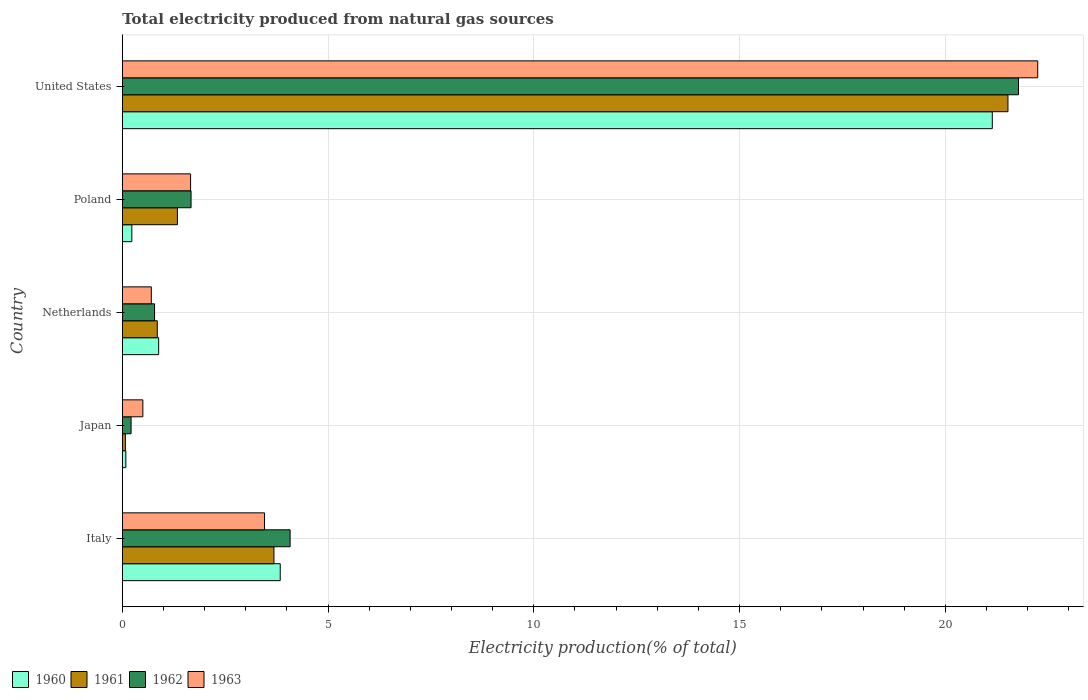How many different coloured bars are there?
Offer a very short reply. 4. Are the number of bars per tick equal to the number of legend labels?
Provide a succinct answer. Yes. How many bars are there on the 3rd tick from the top?
Provide a succinct answer. 4. How many bars are there on the 2nd tick from the bottom?
Offer a terse response. 4. In how many cases, is the number of bars for a given country not equal to the number of legend labels?
Your response must be concise. 0. What is the total electricity produced in 1962 in Poland?
Make the answer very short. 1.67. Across all countries, what is the maximum total electricity produced in 1963?
Your response must be concise. 22.24. Across all countries, what is the minimum total electricity produced in 1960?
Keep it short and to the point. 0.09. In which country was the total electricity produced in 1961 maximum?
Keep it short and to the point. United States. What is the total total electricity produced in 1960 in the graph?
Make the answer very short. 26.18. What is the difference between the total electricity produced in 1960 in Italy and that in United States?
Your answer should be very brief. -17.3. What is the difference between the total electricity produced in 1960 in United States and the total electricity produced in 1962 in Netherlands?
Provide a succinct answer. 20.36. What is the average total electricity produced in 1962 per country?
Provide a succinct answer. 5.71. What is the difference between the total electricity produced in 1963 and total electricity produced in 1962 in Poland?
Offer a very short reply. -0.01. What is the ratio of the total electricity produced in 1960 in Italy to that in Poland?
Make the answer very short. 16.53. What is the difference between the highest and the second highest total electricity produced in 1961?
Your answer should be compact. 17.84. What is the difference between the highest and the lowest total electricity produced in 1961?
Give a very brief answer. 21.45. In how many countries, is the total electricity produced in 1961 greater than the average total electricity produced in 1961 taken over all countries?
Make the answer very short. 1. Is the sum of the total electricity produced in 1962 in Italy and Poland greater than the maximum total electricity produced in 1960 across all countries?
Your answer should be very brief. No. Is it the case that in every country, the sum of the total electricity produced in 1961 and total electricity produced in 1963 is greater than the sum of total electricity produced in 1960 and total electricity produced in 1962?
Offer a terse response. No. What does the 1st bar from the top in Netherlands represents?
Provide a succinct answer. 1963. What does the 1st bar from the bottom in Italy represents?
Your answer should be very brief. 1960. What is the difference between two consecutive major ticks on the X-axis?
Ensure brevity in your answer.  5. Does the graph contain grids?
Ensure brevity in your answer.  Yes. How many legend labels are there?
Offer a very short reply. 4. How are the legend labels stacked?
Offer a terse response. Horizontal. What is the title of the graph?
Your answer should be very brief. Total electricity produced from natural gas sources. What is the Electricity production(% of total) in 1960 in Italy?
Your answer should be compact. 3.84. What is the Electricity production(% of total) in 1961 in Italy?
Give a very brief answer. 3.69. What is the Electricity production(% of total) in 1962 in Italy?
Offer a terse response. 4.08. What is the Electricity production(% of total) of 1963 in Italy?
Your response must be concise. 3.46. What is the Electricity production(% of total) of 1960 in Japan?
Your answer should be compact. 0.09. What is the Electricity production(% of total) of 1961 in Japan?
Make the answer very short. 0.08. What is the Electricity production(% of total) in 1962 in Japan?
Offer a terse response. 0.21. What is the Electricity production(% of total) of 1963 in Japan?
Give a very brief answer. 0.5. What is the Electricity production(% of total) of 1960 in Netherlands?
Ensure brevity in your answer.  0.88. What is the Electricity production(% of total) of 1961 in Netherlands?
Offer a terse response. 0.85. What is the Electricity production(% of total) of 1962 in Netherlands?
Offer a terse response. 0.78. What is the Electricity production(% of total) of 1963 in Netherlands?
Give a very brief answer. 0.71. What is the Electricity production(% of total) of 1960 in Poland?
Give a very brief answer. 0.23. What is the Electricity production(% of total) of 1961 in Poland?
Provide a short and direct response. 1.34. What is the Electricity production(% of total) of 1962 in Poland?
Offer a terse response. 1.67. What is the Electricity production(% of total) of 1963 in Poland?
Your answer should be very brief. 1.66. What is the Electricity production(% of total) of 1960 in United States?
Make the answer very short. 21.14. What is the Electricity production(% of total) in 1961 in United States?
Offer a terse response. 21.52. What is the Electricity production(% of total) in 1962 in United States?
Ensure brevity in your answer.  21.78. What is the Electricity production(% of total) of 1963 in United States?
Give a very brief answer. 22.24. Across all countries, what is the maximum Electricity production(% of total) in 1960?
Offer a terse response. 21.14. Across all countries, what is the maximum Electricity production(% of total) of 1961?
Offer a terse response. 21.52. Across all countries, what is the maximum Electricity production(% of total) of 1962?
Your response must be concise. 21.78. Across all countries, what is the maximum Electricity production(% of total) of 1963?
Provide a short and direct response. 22.24. Across all countries, what is the minimum Electricity production(% of total) in 1960?
Provide a succinct answer. 0.09. Across all countries, what is the minimum Electricity production(% of total) in 1961?
Provide a short and direct response. 0.08. Across all countries, what is the minimum Electricity production(% of total) in 1962?
Provide a succinct answer. 0.21. Across all countries, what is the minimum Electricity production(% of total) in 1963?
Your answer should be compact. 0.5. What is the total Electricity production(% of total) in 1960 in the graph?
Your response must be concise. 26.18. What is the total Electricity production(% of total) of 1961 in the graph?
Ensure brevity in your answer.  27.47. What is the total Electricity production(% of total) of 1962 in the graph?
Give a very brief answer. 28.53. What is the total Electricity production(% of total) in 1963 in the graph?
Provide a succinct answer. 28.57. What is the difference between the Electricity production(% of total) in 1960 in Italy and that in Japan?
Make the answer very short. 3.75. What is the difference between the Electricity production(% of total) in 1961 in Italy and that in Japan?
Offer a terse response. 3.61. What is the difference between the Electricity production(% of total) in 1962 in Italy and that in Japan?
Make the answer very short. 3.86. What is the difference between the Electricity production(% of total) in 1963 in Italy and that in Japan?
Your response must be concise. 2.96. What is the difference between the Electricity production(% of total) of 1960 in Italy and that in Netherlands?
Provide a short and direct response. 2.95. What is the difference between the Electricity production(% of total) of 1961 in Italy and that in Netherlands?
Your response must be concise. 2.83. What is the difference between the Electricity production(% of total) in 1962 in Italy and that in Netherlands?
Offer a very short reply. 3.29. What is the difference between the Electricity production(% of total) in 1963 in Italy and that in Netherlands?
Make the answer very short. 2.75. What is the difference between the Electricity production(% of total) of 1960 in Italy and that in Poland?
Provide a succinct answer. 3.61. What is the difference between the Electricity production(% of total) of 1961 in Italy and that in Poland?
Your answer should be compact. 2.35. What is the difference between the Electricity production(% of total) in 1962 in Italy and that in Poland?
Give a very brief answer. 2.41. What is the difference between the Electricity production(% of total) in 1963 in Italy and that in Poland?
Offer a terse response. 1.8. What is the difference between the Electricity production(% of total) of 1960 in Italy and that in United States?
Offer a very short reply. -17.3. What is the difference between the Electricity production(% of total) in 1961 in Italy and that in United States?
Your answer should be very brief. -17.84. What is the difference between the Electricity production(% of total) of 1962 in Italy and that in United States?
Your response must be concise. -17.7. What is the difference between the Electricity production(% of total) of 1963 in Italy and that in United States?
Your response must be concise. -18.79. What is the difference between the Electricity production(% of total) in 1960 in Japan and that in Netherlands?
Give a very brief answer. -0.8. What is the difference between the Electricity production(% of total) of 1961 in Japan and that in Netherlands?
Your answer should be very brief. -0.78. What is the difference between the Electricity production(% of total) in 1962 in Japan and that in Netherlands?
Your answer should be compact. -0.57. What is the difference between the Electricity production(% of total) of 1963 in Japan and that in Netherlands?
Keep it short and to the point. -0.21. What is the difference between the Electricity production(% of total) in 1960 in Japan and that in Poland?
Ensure brevity in your answer.  -0.15. What is the difference between the Electricity production(% of total) in 1961 in Japan and that in Poland?
Keep it short and to the point. -1.26. What is the difference between the Electricity production(% of total) in 1962 in Japan and that in Poland?
Keep it short and to the point. -1.46. What is the difference between the Electricity production(% of total) in 1963 in Japan and that in Poland?
Your response must be concise. -1.16. What is the difference between the Electricity production(% of total) in 1960 in Japan and that in United States?
Your response must be concise. -21.05. What is the difference between the Electricity production(% of total) of 1961 in Japan and that in United States?
Offer a terse response. -21.45. What is the difference between the Electricity production(% of total) of 1962 in Japan and that in United States?
Ensure brevity in your answer.  -21.56. What is the difference between the Electricity production(% of total) of 1963 in Japan and that in United States?
Offer a terse response. -21.74. What is the difference between the Electricity production(% of total) in 1960 in Netherlands and that in Poland?
Your response must be concise. 0.65. What is the difference between the Electricity production(% of total) of 1961 in Netherlands and that in Poland?
Offer a very short reply. -0.49. What is the difference between the Electricity production(% of total) of 1962 in Netherlands and that in Poland?
Offer a very short reply. -0.89. What is the difference between the Electricity production(% of total) in 1963 in Netherlands and that in Poland?
Keep it short and to the point. -0.95. What is the difference between the Electricity production(% of total) in 1960 in Netherlands and that in United States?
Offer a very short reply. -20.26. What is the difference between the Electricity production(% of total) of 1961 in Netherlands and that in United States?
Your answer should be very brief. -20.67. What is the difference between the Electricity production(% of total) of 1962 in Netherlands and that in United States?
Your response must be concise. -20.99. What is the difference between the Electricity production(% of total) of 1963 in Netherlands and that in United States?
Ensure brevity in your answer.  -21.54. What is the difference between the Electricity production(% of total) in 1960 in Poland and that in United States?
Make the answer very short. -20.91. What is the difference between the Electricity production(% of total) in 1961 in Poland and that in United States?
Offer a very short reply. -20.18. What is the difference between the Electricity production(% of total) in 1962 in Poland and that in United States?
Your response must be concise. -20.11. What is the difference between the Electricity production(% of total) in 1963 in Poland and that in United States?
Keep it short and to the point. -20.59. What is the difference between the Electricity production(% of total) of 1960 in Italy and the Electricity production(% of total) of 1961 in Japan?
Make the answer very short. 3.76. What is the difference between the Electricity production(% of total) in 1960 in Italy and the Electricity production(% of total) in 1962 in Japan?
Provide a succinct answer. 3.62. What is the difference between the Electricity production(% of total) of 1960 in Italy and the Electricity production(% of total) of 1963 in Japan?
Your answer should be very brief. 3.34. What is the difference between the Electricity production(% of total) in 1961 in Italy and the Electricity production(% of total) in 1962 in Japan?
Provide a short and direct response. 3.47. What is the difference between the Electricity production(% of total) of 1961 in Italy and the Electricity production(% of total) of 1963 in Japan?
Your answer should be very brief. 3.19. What is the difference between the Electricity production(% of total) of 1962 in Italy and the Electricity production(% of total) of 1963 in Japan?
Give a very brief answer. 3.58. What is the difference between the Electricity production(% of total) of 1960 in Italy and the Electricity production(% of total) of 1961 in Netherlands?
Give a very brief answer. 2.99. What is the difference between the Electricity production(% of total) in 1960 in Italy and the Electricity production(% of total) in 1962 in Netherlands?
Your answer should be compact. 3.05. What is the difference between the Electricity production(% of total) in 1960 in Italy and the Electricity production(% of total) in 1963 in Netherlands?
Provide a succinct answer. 3.13. What is the difference between the Electricity production(% of total) in 1961 in Italy and the Electricity production(% of total) in 1962 in Netherlands?
Keep it short and to the point. 2.9. What is the difference between the Electricity production(% of total) in 1961 in Italy and the Electricity production(% of total) in 1963 in Netherlands?
Your response must be concise. 2.98. What is the difference between the Electricity production(% of total) in 1962 in Italy and the Electricity production(% of total) in 1963 in Netherlands?
Your answer should be compact. 3.37. What is the difference between the Electricity production(% of total) of 1960 in Italy and the Electricity production(% of total) of 1961 in Poland?
Provide a succinct answer. 2.5. What is the difference between the Electricity production(% of total) in 1960 in Italy and the Electricity production(% of total) in 1962 in Poland?
Provide a succinct answer. 2.17. What is the difference between the Electricity production(% of total) in 1960 in Italy and the Electricity production(% of total) in 1963 in Poland?
Offer a very short reply. 2.18. What is the difference between the Electricity production(% of total) in 1961 in Italy and the Electricity production(% of total) in 1962 in Poland?
Offer a very short reply. 2.01. What is the difference between the Electricity production(% of total) in 1961 in Italy and the Electricity production(% of total) in 1963 in Poland?
Make the answer very short. 2.03. What is the difference between the Electricity production(% of total) in 1962 in Italy and the Electricity production(% of total) in 1963 in Poland?
Offer a terse response. 2.42. What is the difference between the Electricity production(% of total) in 1960 in Italy and the Electricity production(% of total) in 1961 in United States?
Give a very brief answer. -17.68. What is the difference between the Electricity production(% of total) in 1960 in Italy and the Electricity production(% of total) in 1962 in United States?
Your answer should be very brief. -17.94. What is the difference between the Electricity production(% of total) in 1960 in Italy and the Electricity production(% of total) in 1963 in United States?
Make the answer very short. -18.41. What is the difference between the Electricity production(% of total) of 1961 in Italy and the Electricity production(% of total) of 1962 in United States?
Ensure brevity in your answer.  -18.09. What is the difference between the Electricity production(% of total) in 1961 in Italy and the Electricity production(% of total) in 1963 in United States?
Make the answer very short. -18.56. What is the difference between the Electricity production(% of total) of 1962 in Italy and the Electricity production(% of total) of 1963 in United States?
Your response must be concise. -18.17. What is the difference between the Electricity production(% of total) in 1960 in Japan and the Electricity production(% of total) in 1961 in Netherlands?
Your answer should be very brief. -0.76. What is the difference between the Electricity production(% of total) in 1960 in Japan and the Electricity production(% of total) in 1962 in Netherlands?
Keep it short and to the point. -0.7. What is the difference between the Electricity production(% of total) of 1960 in Japan and the Electricity production(% of total) of 1963 in Netherlands?
Offer a very short reply. -0.62. What is the difference between the Electricity production(% of total) of 1961 in Japan and the Electricity production(% of total) of 1962 in Netherlands?
Give a very brief answer. -0.71. What is the difference between the Electricity production(% of total) of 1961 in Japan and the Electricity production(% of total) of 1963 in Netherlands?
Provide a short and direct response. -0.63. What is the difference between the Electricity production(% of total) in 1962 in Japan and the Electricity production(% of total) in 1963 in Netherlands?
Offer a very short reply. -0.49. What is the difference between the Electricity production(% of total) in 1960 in Japan and the Electricity production(% of total) in 1961 in Poland?
Your response must be concise. -1.25. What is the difference between the Electricity production(% of total) in 1960 in Japan and the Electricity production(% of total) in 1962 in Poland?
Offer a very short reply. -1.58. What is the difference between the Electricity production(% of total) of 1960 in Japan and the Electricity production(% of total) of 1963 in Poland?
Your answer should be very brief. -1.57. What is the difference between the Electricity production(% of total) in 1961 in Japan and the Electricity production(% of total) in 1962 in Poland?
Give a very brief answer. -1.6. What is the difference between the Electricity production(% of total) of 1961 in Japan and the Electricity production(% of total) of 1963 in Poland?
Keep it short and to the point. -1.58. What is the difference between the Electricity production(% of total) in 1962 in Japan and the Electricity production(% of total) in 1963 in Poland?
Offer a terse response. -1.45. What is the difference between the Electricity production(% of total) of 1960 in Japan and the Electricity production(% of total) of 1961 in United States?
Ensure brevity in your answer.  -21.43. What is the difference between the Electricity production(% of total) in 1960 in Japan and the Electricity production(% of total) in 1962 in United States?
Ensure brevity in your answer.  -21.69. What is the difference between the Electricity production(% of total) of 1960 in Japan and the Electricity production(% of total) of 1963 in United States?
Your response must be concise. -22.16. What is the difference between the Electricity production(% of total) in 1961 in Japan and the Electricity production(% of total) in 1962 in United States?
Keep it short and to the point. -21.7. What is the difference between the Electricity production(% of total) in 1961 in Japan and the Electricity production(% of total) in 1963 in United States?
Give a very brief answer. -22.17. What is the difference between the Electricity production(% of total) in 1962 in Japan and the Electricity production(% of total) in 1963 in United States?
Provide a succinct answer. -22.03. What is the difference between the Electricity production(% of total) in 1960 in Netherlands and the Electricity production(% of total) in 1961 in Poland?
Ensure brevity in your answer.  -0.46. What is the difference between the Electricity production(% of total) in 1960 in Netherlands and the Electricity production(% of total) in 1962 in Poland?
Make the answer very short. -0.79. What is the difference between the Electricity production(% of total) in 1960 in Netherlands and the Electricity production(% of total) in 1963 in Poland?
Your answer should be very brief. -0.78. What is the difference between the Electricity production(% of total) of 1961 in Netherlands and the Electricity production(% of total) of 1962 in Poland?
Offer a terse response. -0.82. What is the difference between the Electricity production(% of total) of 1961 in Netherlands and the Electricity production(% of total) of 1963 in Poland?
Make the answer very short. -0.81. What is the difference between the Electricity production(% of total) in 1962 in Netherlands and the Electricity production(% of total) in 1963 in Poland?
Offer a very short reply. -0.88. What is the difference between the Electricity production(% of total) of 1960 in Netherlands and the Electricity production(% of total) of 1961 in United States?
Provide a short and direct response. -20.64. What is the difference between the Electricity production(% of total) in 1960 in Netherlands and the Electricity production(% of total) in 1962 in United States?
Keep it short and to the point. -20.89. What is the difference between the Electricity production(% of total) in 1960 in Netherlands and the Electricity production(% of total) in 1963 in United States?
Your response must be concise. -21.36. What is the difference between the Electricity production(% of total) in 1961 in Netherlands and the Electricity production(% of total) in 1962 in United States?
Your response must be concise. -20.93. What is the difference between the Electricity production(% of total) in 1961 in Netherlands and the Electricity production(% of total) in 1963 in United States?
Give a very brief answer. -21.39. What is the difference between the Electricity production(% of total) in 1962 in Netherlands and the Electricity production(% of total) in 1963 in United States?
Offer a very short reply. -21.46. What is the difference between the Electricity production(% of total) in 1960 in Poland and the Electricity production(% of total) in 1961 in United States?
Offer a very short reply. -21.29. What is the difference between the Electricity production(% of total) in 1960 in Poland and the Electricity production(% of total) in 1962 in United States?
Your answer should be compact. -21.55. What is the difference between the Electricity production(% of total) in 1960 in Poland and the Electricity production(% of total) in 1963 in United States?
Offer a very short reply. -22.01. What is the difference between the Electricity production(% of total) in 1961 in Poland and the Electricity production(% of total) in 1962 in United States?
Ensure brevity in your answer.  -20.44. What is the difference between the Electricity production(% of total) in 1961 in Poland and the Electricity production(% of total) in 1963 in United States?
Make the answer very short. -20.91. What is the difference between the Electricity production(% of total) in 1962 in Poland and the Electricity production(% of total) in 1963 in United States?
Give a very brief answer. -20.57. What is the average Electricity production(% of total) of 1960 per country?
Offer a terse response. 5.24. What is the average Electricity production(% of total) of 1961 per country?
Your response must be concise. 5.49. What is the average Electricity production(% of total) in 1962 per country?
Ensure brevity in your answer.  5.71. What is the average Electricity production(% of total) in 1963 per country?
Offer a very short reply. 5.71. What is the difference between the Electricity production(% of total) in 1960 and Electricity production(% of total) in 1961 in Italy?
Keep it short and to the point. 0.15. What is the difference between the Electricity production(% of total) of 1960 and Electricity production(% of total) of 1962 in Italy?
Your answer should be compact. -0.24. What is the difference between the Electricity production(% of total) of 1960 and Electricity production(% of total) of 1963 in Italy?
Make the answer very short. 0.38. What is the difference between the Electricity production(% of total) of 1961 and Electricity production(% of total) of 1962 in Italy?
Offer a terse response. -0.39. What is the difference between the Electricity production(% of total) in 1961 and Electricity production(% of total) in 1963 in Italy?
Ensure brevity in your answer.  0.23. What is the difference between the Electricity production(% of total) of 1962 and Electricity production(% of total) of 1963 in Italy?
Your response must be concise. 0.62. What is the difference between the Electricity production(% of total) in 1960 and Electricity production(% of total) in 1961 in Japan?
Provide a short and direct response. 0.01. What is the difference between the Electricity production(% of total) in 1960 and Electricity production(% of total) in 1962 in Japan?
Your answer should be very brief. -0.13. What is the difference between the Electricity production(% of total) in 1960 and Electricity production(% of total) in 1963 in Japan?
Make the answer very short. -0.41. What is the difference between the Electricity production(% of total) in 1961 and Electricity production(% of total) in 1962 in Japan?
Make the answer very short. -0.14. What is the difference between the Electricity production(% of total) of 1961 and Electricity production(% of total) of 1963 in Japan?
Provide a short and direct response. -0.42. What is the difference between the Electricity production(% of total) in 1962 and Electricity production(% of total) in 1963 in Japan?
Your response must be concise. -0.29. What is the difference between the Electricity production(% of total) of 1960 and Electricity production(% of total) of 1961 in Netherlands?
Ensure brevity in your answer.  0.03. What is the difference between the Electricity production(% of total) of 1960 and Electricity production(% of total) of 1962 in Netherlands?
Provide a short and direct response. 0.1. What is the difference between the Electricity production(% of total) of 1960 and Electricity production(% of total) of 1963 in Netherlands?
Offer a very short reply. 0.18. What is the difference between the Electricity production(% of total) of 1961 and Electricity production(% of total) of 1962 in Netherlands?
Your answer should be compact. 0.07. What is the difference between the Electricity production(% of total) in 1961 and Electricity production(% of total) in 1963 in Netherlands?
Make the answer very short. 0.15. What is the difference between the Electricity production(% of total) in 1962 and Electricity production(% of total) in 1963 in Netherlands?
Ensure brevity in your answer.  0.08. What is the difference between the Electricity production(% of total) in 1960 and Electricity production(% of total) in 1961 in Poland?
Your answer should be compact. -1.11. What is the difference between the Electricity production(% of total) in 1960 and Electricity production(% of total) in 1962 in Poland?
Offer a very short reply. -1.44. What is the difference between the Electricity production(% of total) of 1960 and Electricity production(% of total) of 1963 in Poland?
Provide a short and direct response. -1.43. What is the difference between the Electricity production(% of total) in 1961 and Electricity production(% of total) in 1962 in Poland?
Give a very brief answer. -0.33. What is the difference between the Electricity production(% of total) in 1961 and Electricity production(% of total) in 1963 in Poland?
Make the answer very short. -0.32. What is the difference between the Electricity production(% of total) of 1962 and Electricity production(% of total) of 1963 in Poland?
Provide a short and direct response. 0.01. What is the difference between the Electricity production(% of total) in 1960 and Electricity production(% of total) in 1961 in United States?
Ensure brevity in your answer.  -0.38. What is the difference between the Electricity production(% of total) in 1960 and Electricity production(% of total) in 1962 in United States?
Provide a short and direct response. -0.64. What is the difference between the Electricity production(% of total) in 1960 and Electricity production(% of total) in 1963 in United States?
Keep it short and to the point. -1.1. What is the difference between the Electricity production(% of total) of 1961 and Electricity production(% of total) of 1962 in United States?
Ensure brevity in your answer.  -0.26. What is the difference between the Electricity production(% of total) of 1961 and Electricity production(% of total) of 1963 in United States?
Your response must be concise. -0.72. What is the difference between the Electricity production(% of total) in 1962 and Electricity production(% of total) in 1963 in United States?
Ensure brevity in your answer.  -0.47. What is the ratio of the Electricity production(% of total) in 1960 in Italy to that in Japan?
Offer a terse response. 44.33. What is the ratio of the Electricity production(% of total) in 1961 in Italy to that in Japan?
Your answer should be very brief. 48.69. What is the ratio of the Electricity production(% of total) of 1962 in Italy to that in Japan?
Provide a succinct answer. 19.09. What is the ratio of the Electricity production(% of total) of 1963 in Italy to that in Japan?
Your answer should be very brief. 6.91. What is the ratio of the Electricity production(% of total) of 1960 in Italy to that in Netherlands?
Give a very brief answer. 4.34. What is the ratio of the Electricity production(% of total) in 1961 in Italy to that in Netherlands?
Ensure brevity in your answer.  4.33. What is the ratio of the Electricity production(% of total) in 1962 in Italy to that in Netherlands?
Give a very brief answer. 5.2. What is the ratio of the Electricity production(% of total) of 1963 in Italy to that in Netherlands?
Ensure brevity in your answer.  4.9. What is the ratio of the Electricity production(% of total) in 1960 in Italy to that in Poland?
Provide a succinct answer. 16.53. What is the ratio of the Electricity production(% of total) in 1961 in Italy to that in Poland?
Make the answer very short. 2.75. What is the ratio of the Electricity production(% of total) of 1962 in Italy to that in Poland?
Provide a short and direct response. 2.44. What is the ratio of the Electricity production(% of total) of 1963 in Italy to that in Poland?
Offer a very short reply. 2.08. What is the ratio of the Electricity production(% of total) in 1960 in Italy to that in United States?
Provide a succinct answer. 0.18. What is the ratio of the Electricity production(% of total) in 1961 in Italy to that in United States?
Your response must be concise. 0.17. What is the ratio of the Electricity production(% of total) in 1962 in Italy to that in United States?
Make the answer very short. 0.19. What is the ratio of the Electricity production(% of total) of 1963 in Italy to that in United States?
Provide a succinct answer. 0.16. What is the ratio of the Electricity production(% of total) of 1960 in Japan to that in Netherlands?
Give a very brief answer. 0.1. What is the ratio of the Electricity production(% of total) of 1961 in Japan to that in Netherlands?
Provide a succinct answer. 0.09. What is the ratio of the Electricity production(% of total) in 1962 in Japan to that in Netherlands?
Keep it short and to the point. 0.27. What is the ratio of the Electricity production(% of total) of 1963 in Japan to that in Netherlands?
Your answer should be compact. 0.71. What is the ratio of the Electricity production(% of total) in 1960 in Japan to that in Poland?
Offer a very short reply. 0.37. What is the ratio of the Electricity production(% of total) of 1961 in Japan to that in Poland?
Keep it short and to the point. 0.06. What is the ratio of the Electricity production(% of total) in 1962 in Japan to that in Poland?
Offer a very short reply. 0.13. What is the ratio of the Electricity production(% of total) of 1963 in Japan to that in Poland?
Your answer should be very brief. 0.3. What is the ratio of the Electricity production(% of total) of 1960 in Japan to that in United States?
Ensure brevity in your answer.  0. What is the ratio of the Electricity production(% of total) in 1961 in Japan to that in United States?
Your answer should be very brief. 0. What is the ratio of the Electricity production(% of total) of 1962 in Japan to that in United States?
Offer a terse response. 0.01. What is the ratio of the Electricity production(% of total) of 1963 in Japan to that in United States?
Keep it short and to the point. 0.02. What is the ratio of the Electricity production(% of total) in 1960 in Netherlands to that in Poland?
Offer a very short reply. 3.81. What is the ratio of the Electricity production(% of total) of 1961 in Netherlands to that in Poland?
Keep it short and to the point. 0.64. What is the ratio of the Electricity production(% of total) in 1962 in Netherlands to that in Poland?
Your answer should be compact. 0.47. What is the ratio of the Electricity production(% of total) in 1963 in Netherlands to that in Poland?
Your response must be concise. 0.42. What is the ratio of the Electricity production(% of total) of 1960 in Netherlands to that in United States?
Your answer should be compact. 0.04. What is the ratio of the Electricity production(% of total) in 1961 in Netherlands to that in United States?
Offer a very short reply. 0.04. What is the ratio of the Electricity production(% of total) in 1962 in Netherlands to that in United States?
Offer a terse response. 0.04. What is the ratio of the Electricity production(% of total) of 1963 in Netherlands to that in United States?
Give a very brief answer. 0.03. What is the ratio of the Electricity production(% of total) of 1960 in Poland to that in United States?
Provide a succinct answer. 0.01. What is the ratio of the Electricity production(% of total) of 1961 in Poland to that in United States?
Your answer should be compact. 0.06. What is the ratio of the Electricity production(% of total) of 1962 in Poland to that in United States?
Ensure brevity in your answer.  0.08. What is the ratio of the Electricity production(% of total) of 1963 in Poland to that in United States?
Ensure brevity in your answer.  0.07. What is the difference between the highest and the second highest Electricity production(% of total) in 1960?
Provide a short and direct response. 17.3. What is the difference between the highest and the second highest Electricity production(% of total) of 1961?
Your response must be concise. 17.84. What is the difference between the highest and the second highest Electricity production(% of total) of 1962?
Keep it short and to the point. 17.7. What is the difference between the highest and the second highest Electricity production(% of total) in 1963?
Offer a very short reply. 18.79. What is the difference between the highest and the lowest Electricity production(% of total) of 1960?
Keep it short and to the point. 21.05. What is the difference between the highest and the lowest Electricity production(% of total) of 1961?
Your answer should be very brief. 21.45. What is the difference between the highest and the lowest Electricity production(% of total) of 1962?
Provide a succinct answer. 21.56. What is the difference between the highest and the lowest Electricity production(% of total) in 1963?
Your answer should be compact. 21.74. 